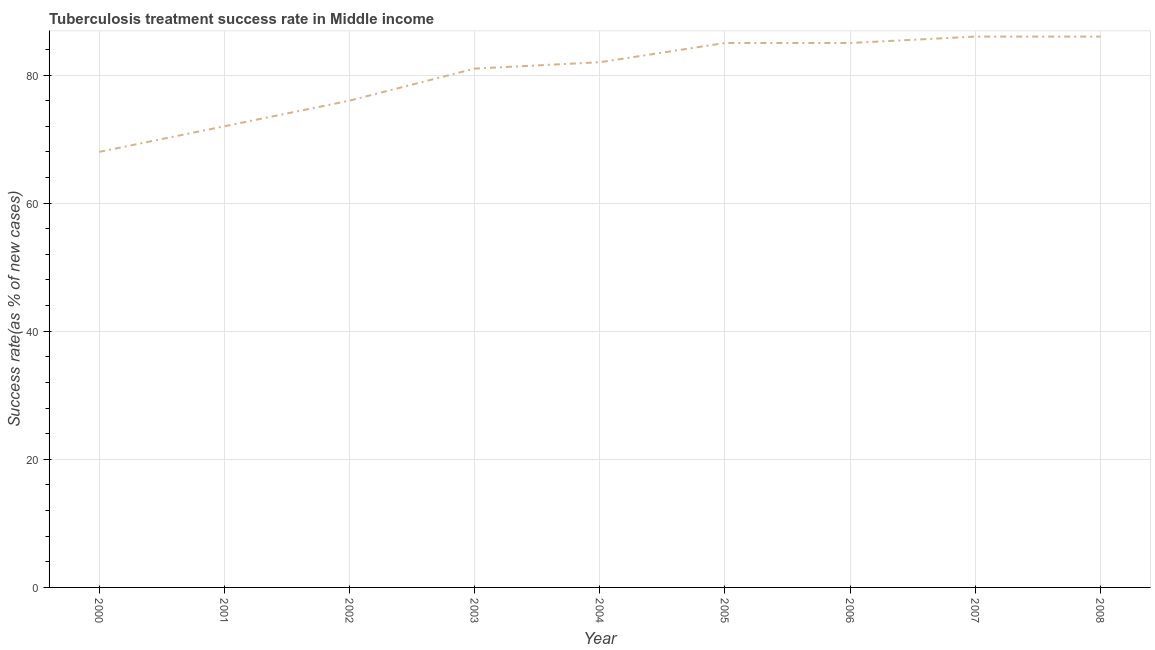What is the tuberculosis treatment success rate in 2002?
Provide a short and direct response. 76. Across all years, what is the maximum tuberculosis treatment success rate?
Keep it short and to the point. 86. Across all years, what is the minimum tuberculosis treatment success rate?
Give a very brief answer. 68. What is the sum of the tuberculosis treatment success rate?
Ensure brevity in your answer.  721. What is the difference between the tuberculosis treatment success rate in 2002 and 2004?
Provide a succinct answer. -6. What is the average tuberculosis treatment success rate per year?
Give a very brief answer. 80.11. In how many years, is the tuberculosis treatment success rate greater than 20 %?
Provide a succinct answer. 9. Do a majority of the years between 2005 and 2007 (inclusive) have tuberculosis treatment success rate greater than 12 %?
Offer a very short reply. Yes. What is the ratio of the tuberculosis treatment success rate in 2004 to that in 2007?
Your answer should be very brief. 0.95. What is the difference between the highest and the lowest tuberculosis treatment success rate?
Offer a very short reply. 18. Does the tuberculosis treatment success rate monotonically increase over the years?
Provide a short and direct response. No. Are the values on the major ticks of Y-axis written in scientific E-notation?
Offer a very short reply. No. Does the graph contain grids?
Your answer should be very brief. Yes. What is the title of the graph?
Provide a succinct answer. Tuberculosis treatment success rate in Middle income. What is the label or title of the X-axis?
Your response must be concise. Year. What is the label or title of the Y-axis?
Your response must be concise. Success rate(as % of new cases). What is the Success rate(as % of new cases) in 2007?
Offer a terse response. 86. What is the Success rate(as % of new cases) in 2008?
Provide a short and direct response. 86. What is the difference between the Success rate(as % of new cases) in 2000 and 2003?
Make the answer very short. -13. What is the difference between the Success rate(as % of new cases) in 2000 and 2004?
Your response must be concise. -14. What is the difference between the Success rate(as % of new cases) in 2000 and 2005?
Your answer should be compact. -17. What is the difference between the Success rate(as % of new cases) in 2000 and 2006?
Offer a terse response. -17. What is the difference between the Success rate(as % of new cases) in 2000 and 2008?
Give a very brief answer. -18. What is the difference between the Success rate(as % of new cases) in 2001 and 2006?
Keep it short and to the point. -13. What is the difference between the Success rate(as % of new cases) in 2001 and 2008?
Your answer should be compact. -14. What is the difference between the Success rate(as % of new cases) in 2002 and 2003?
Provide a succinct answer. -5. What is the difference between the Success rate(as % of new cases) in 2002 and 2006?
Offer a terse response. -9. What is the difference between the Success rate(as % of new cases) in 2002 and 2008?
Your response must be concise. -10. What is the difference between the Success rate(as % of new cases) in 2004 and 2006?
Your answer should be compact. -3. What is the difference between the Success rate(as % of new cases) in 2004 and 2007?
Make the answer very short. -4. What is the difference between the Success rate(as % of new cases) in 2004 and 2008?
Provide a succinct answer. -4. What is the difference between the Success rate(as % of new cases) in 2005 and 2006?
Your answer should be very brief. 0. What is the difference between the Success rate(as % of new cases) in 2005 and 2007?
Offer a very short reply. -1. What is the difference between the Success rate(as % of new cases) in 2006 and 2007?
Ensure brevity in your answer.  -1. What is the difference between the Success rate(as % of new cases) in 2007 and 2008?
Your answer should be very brief. 0. What is the ratio of the Success rate(as % of new cases) in 2000 to that in 2001?
Provide a succinct answer. 0.94. What is the ratio of the Success rate(as % of new cases) in 2000 to that in 2002?
Your answer should be very brief. 0.9. What is the ratio of the Success rate(as % of new cases) in 2000 to that in 2003?
Provide a short and direct response. 0.84. What is the ratio of the Success rate(as % of new cases) in 2000 to that in 2004?
Offer a very short reply. 0.83. What is the ratio of the Success rate(as % of new cases) in 2000 to that in 2007?
Ensure brevity in your answer.  0.79. What is the ratio of the Success rate(as % of new cases) in 2000 to that in 2008?
Provide a succinct answer. 0.79. What is the ratio of the Success rate(as % of new cases) in 2001 to that in 2002?
Keep it short and to the point. 0.95. What is the ratio of the Success rate(as % of new cases) in 2001 to that in 2003?
Your answer should be very brief. 0.89. What is the ratio of the Success rate(as % of new cases) in 2001 to that in 2004?
Keep it short and to the point. 0.88. What is the ratio of the Success rate(as % of new cases) in 2001 to that in 2005?
Your answer should be compact. 0.85. What is the ratio of the Success rate(as % of new cases) in 2001 to that in 2006?
Ensure brevity in your answer.  0.85. What is the ratio of the Success rate(as % of new cases) in 2001 to that in 2007?
Your response must be concise. 0.84. What is the ratio of the Success rate(as % of new cases) in 2001 to that in 2008?
Ensure brevity in your answer.  0.84. What is the ratio of the Success rate(as % of new cases) in 2002 to that in 2003?
Ensure brevity in your answer.  0.94. What is the ratio of the Success rate(as % of new cases) in 2002 to that in 2004?
Your answer should be very brief. 0.93. What is the ratio of the Success rate(as % of new cases) in 2002 to that in 2005?
Make the answer very short. 0.89. What is the ratio of the Success rate(as % of new cases) in 2002 to that in 2006?
Ensure brevity in your answer.  0.89. What is the ratio of the Success rate(as % of new cases) in 2002 to that in 2007?
Offer a very short reply. 0.88. What is the ratio of the Success rate(as % of new cases) in 2002 to that in 2008?
Your answer should be very brief. 0.88. What is the ratio of the Success rate(as % of new cases) in 2003 to that in 2005?
Offer a very short reply. 0.95. What is the ratio of the Success rate(as % of new cases) in 2003 to that in 2006?
Offer a terse response. 0.95. What is the ratio of the Success rate(as % of new cases) in 2003 to that in 2007?
Ensure brevity in your answer.  0.94. What is the ratio of the Success rate(as % of new cases) in 2003 to that in 2008?
Your answer should be very brief. 0.94. What is the ratio of the Success rate(as % of new cases) in 2004 to that in 2006?
Make the answer very short. 0.96. What is the ratio of the Success rate(as % of new cases) in 2004 to that in 2007?
Your answer should be very brief. 0.95. What is the ratio of the Success rate(as % of new cases) in 2004 to that in 2008?
Your answer should be very brief. 0.95. What is the ratio of the Success rate(as % of new cases) in 2006 to that in 2007?
Provide a short and direct response. 0.99. What is the ratio of the Success rate(as % of new cases) in 2006 to that in 2008?
Make the answer very short. 0.99. 